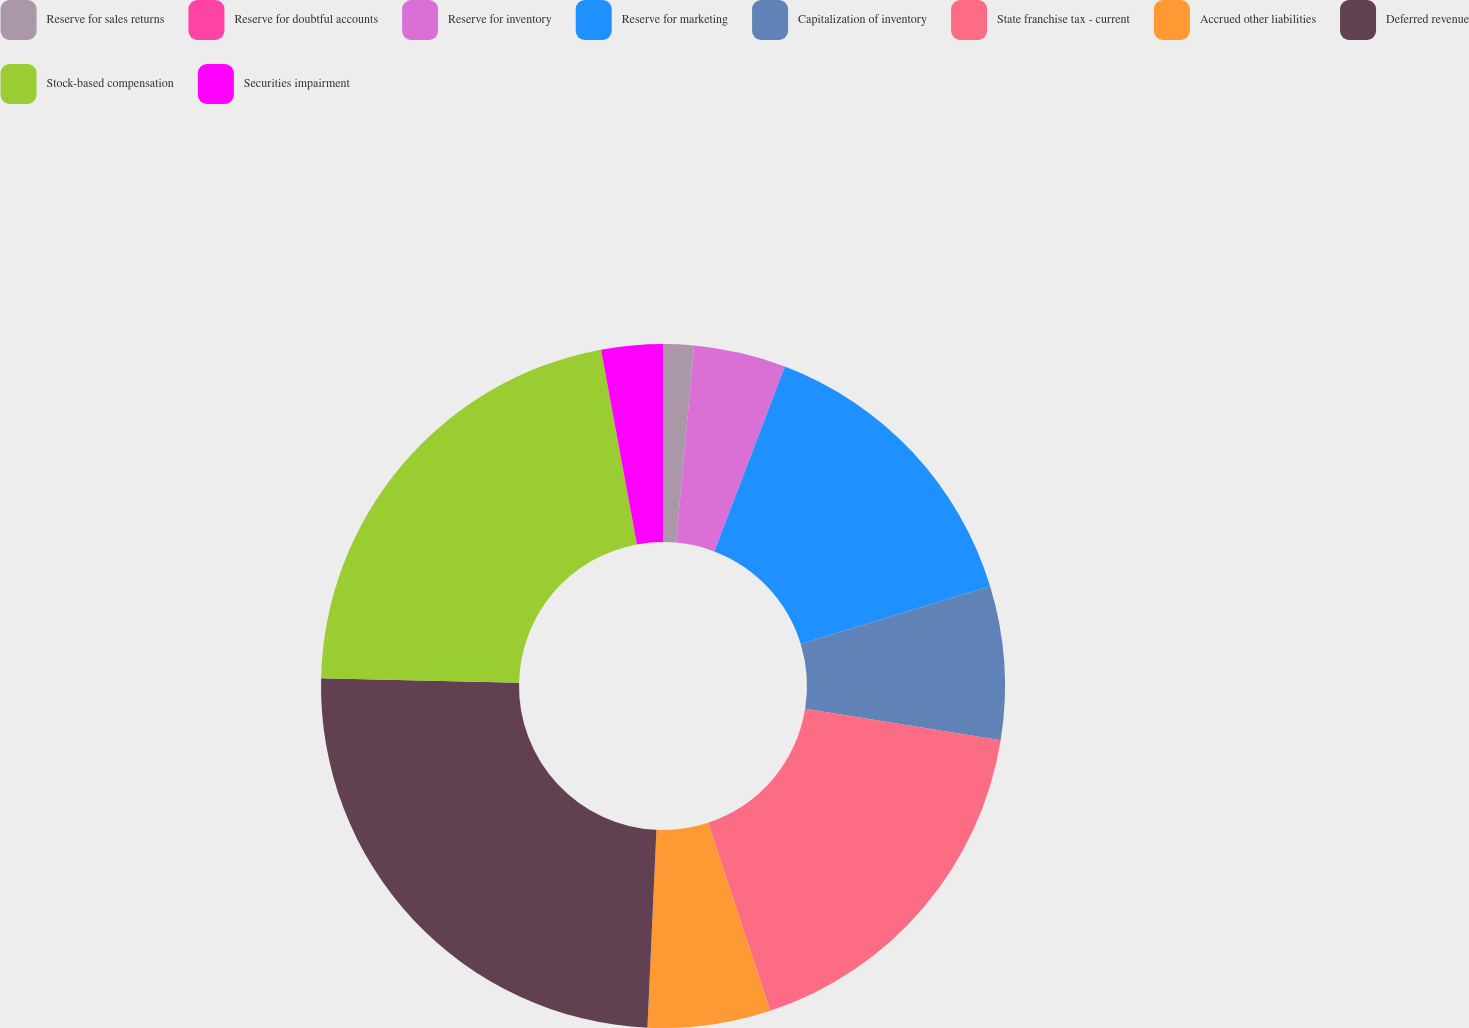<chart> <loc_0><loc_0><loc_500><loc_500><pie_chart><fcel>Reserve for sales returns<fcel>Reserve for doubtful accounts<fcel>Reserve for inventory<fcel>Reserve for marketing<fcel>Capitalization of inventory<fcel>State franchise tax - current<fcel>Accrued other liabilities<fcel>Deferred revenue<fcel>Stock-based compensation<fcel>Securities impairment<nl><fcel>1.45%<fcel>0.0%<fcel>4.35%<fcel>14.49%<fcel>7.25%<fcel>17.39%<fcel>5.8%<fcel>24.64%<fcel>21.74%<fcel>2.9%<nl></chart> 